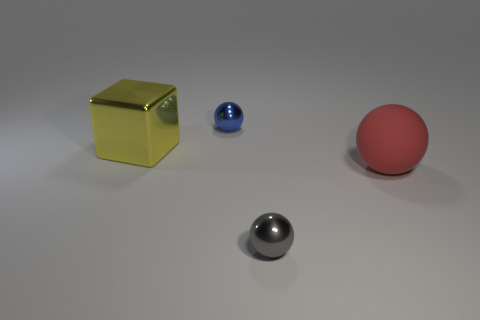What number of tiny things are on the right side of the tiny shiny thing that is behind the metal object in front of the shiny block?
Your answer should be compact. 1. How many big yellow metal cubes are left of the big red thing?
Ensure brevity in your answer.  1. What is the color of the big thing that is the same shape as the tiny gray shiny object?
Offer a terse response. Red. What is the sphere that is behind the tiny gray ball and in front of the yellow thing made of?
Your response must be concise. Rubber. There is a metallic thing that is on the left side of the blue object; does it have the same size as the rubber object?
Give a very brief answer. Yes. What material is the large block?
Provide a succinct answer. Metal. There is a large thing that is to the right of the small gray metallic thing; what is its color?
Give a very brief answer. Red. How many tiny objects are either metallic spheres or cubes?
Offer a very short reply. 2. Is the color of the object that is right of the tiny gray metallic thing the same as the small ball behind the tiny gray shiny sphere?
Your answer should be very brief. No. How many other things are the same color as the metallic cube?
Your answer should be compact. 0. 